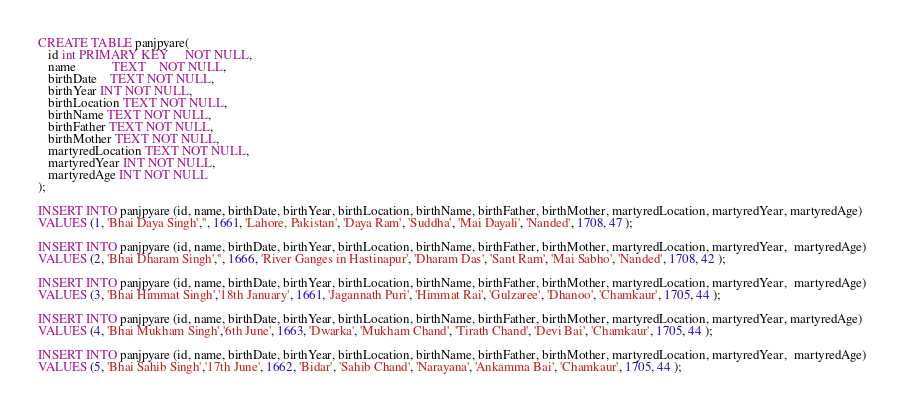Convert code to text. <code><loc_0><loc_0><loc_500><loc_500><_SQL_>CREATE TABLE panjpyare(
   id int PRIMARY KEY     NOT NULL,
   name           TEXT    NOT NULL,
   birthDate    TEXT NOT NULL,
   birthYear INT NOT NULL,
   birthLocation TEXT NOT NULL,
   birthName TEXT NOT NULL,
   birthFather TEXT NOT NULL,
   birthMother TEXT NOT NULL,
   martyredLocation TEXT NOT NULL,
   martyredYear INT NOT NULL,
   martyredAge INT NOT NULL
);

INSERT INTO panjpyare (id, name, birthDate, birthYear, birthLocation, birthName, birthFather, birthMother, martyredLocation, martyredYear, martyredAge)
VALUES (1, 'Bhai Daya Singh','', 1661, 'Lahore, Pakistan', 'Daya Ram', 'Suddha', 'Mai Dayali', 'Nanded', 1708, 47 );

INSERT INTO panjpyare (id, name, birthDate, birthYear, birthLocation, birthName, birthFather, birthMother, martyredLocation, martyredYear,  martyredAge)
VALUES (2, 'Bhai Dharam Singh','', 1666, 'River Ganges in Hastinapur', 'Dharam Das', 'Sant Ram', 'Mai Sabho', 'Nanded', 1708, 42 );

INSERT INTO panjpyare (id, name, birthDate, birthYear, birthLocation, birthName, birthFather, birthMother, martyredLocation, martyredYear,  martyredAge)
VALUES (3, 'Bhai Himmat Singh','18th January', 1661, 'Jagannath Puri', 'Himmat Rai', 'Gulzaree', 'Dhanoo', 'Chamkaur', 1705, 44 );

INSERT INTO panjpyare (id, name, birthDate, birthYear, birthLocation, birthName, birthFather, birthMother, martyredLocation, martyredYear, martyredAge)
VALUES (4, 'Bhai Mukham Singh','6th June', 1663, 'Dwarka', 'Mukham Chand', 'Tirath Chand', 'Devi Bai', 'Chamkaur', 1705, 44 );

INSERT INTO panjpyare (id, name, birthDate, birthYear, birthLocation, birthName, birthFather, birthMother, martyredLocation, martyredYear,  martyredAge)
VALUES (5, 'Bhai Sahib Singh','17th June', 1662, 'Bidar', 'Sahib Chand', 'Narayana', 'Ankamma Bai', 'Chamkaur', 1705, 44 );</code> 